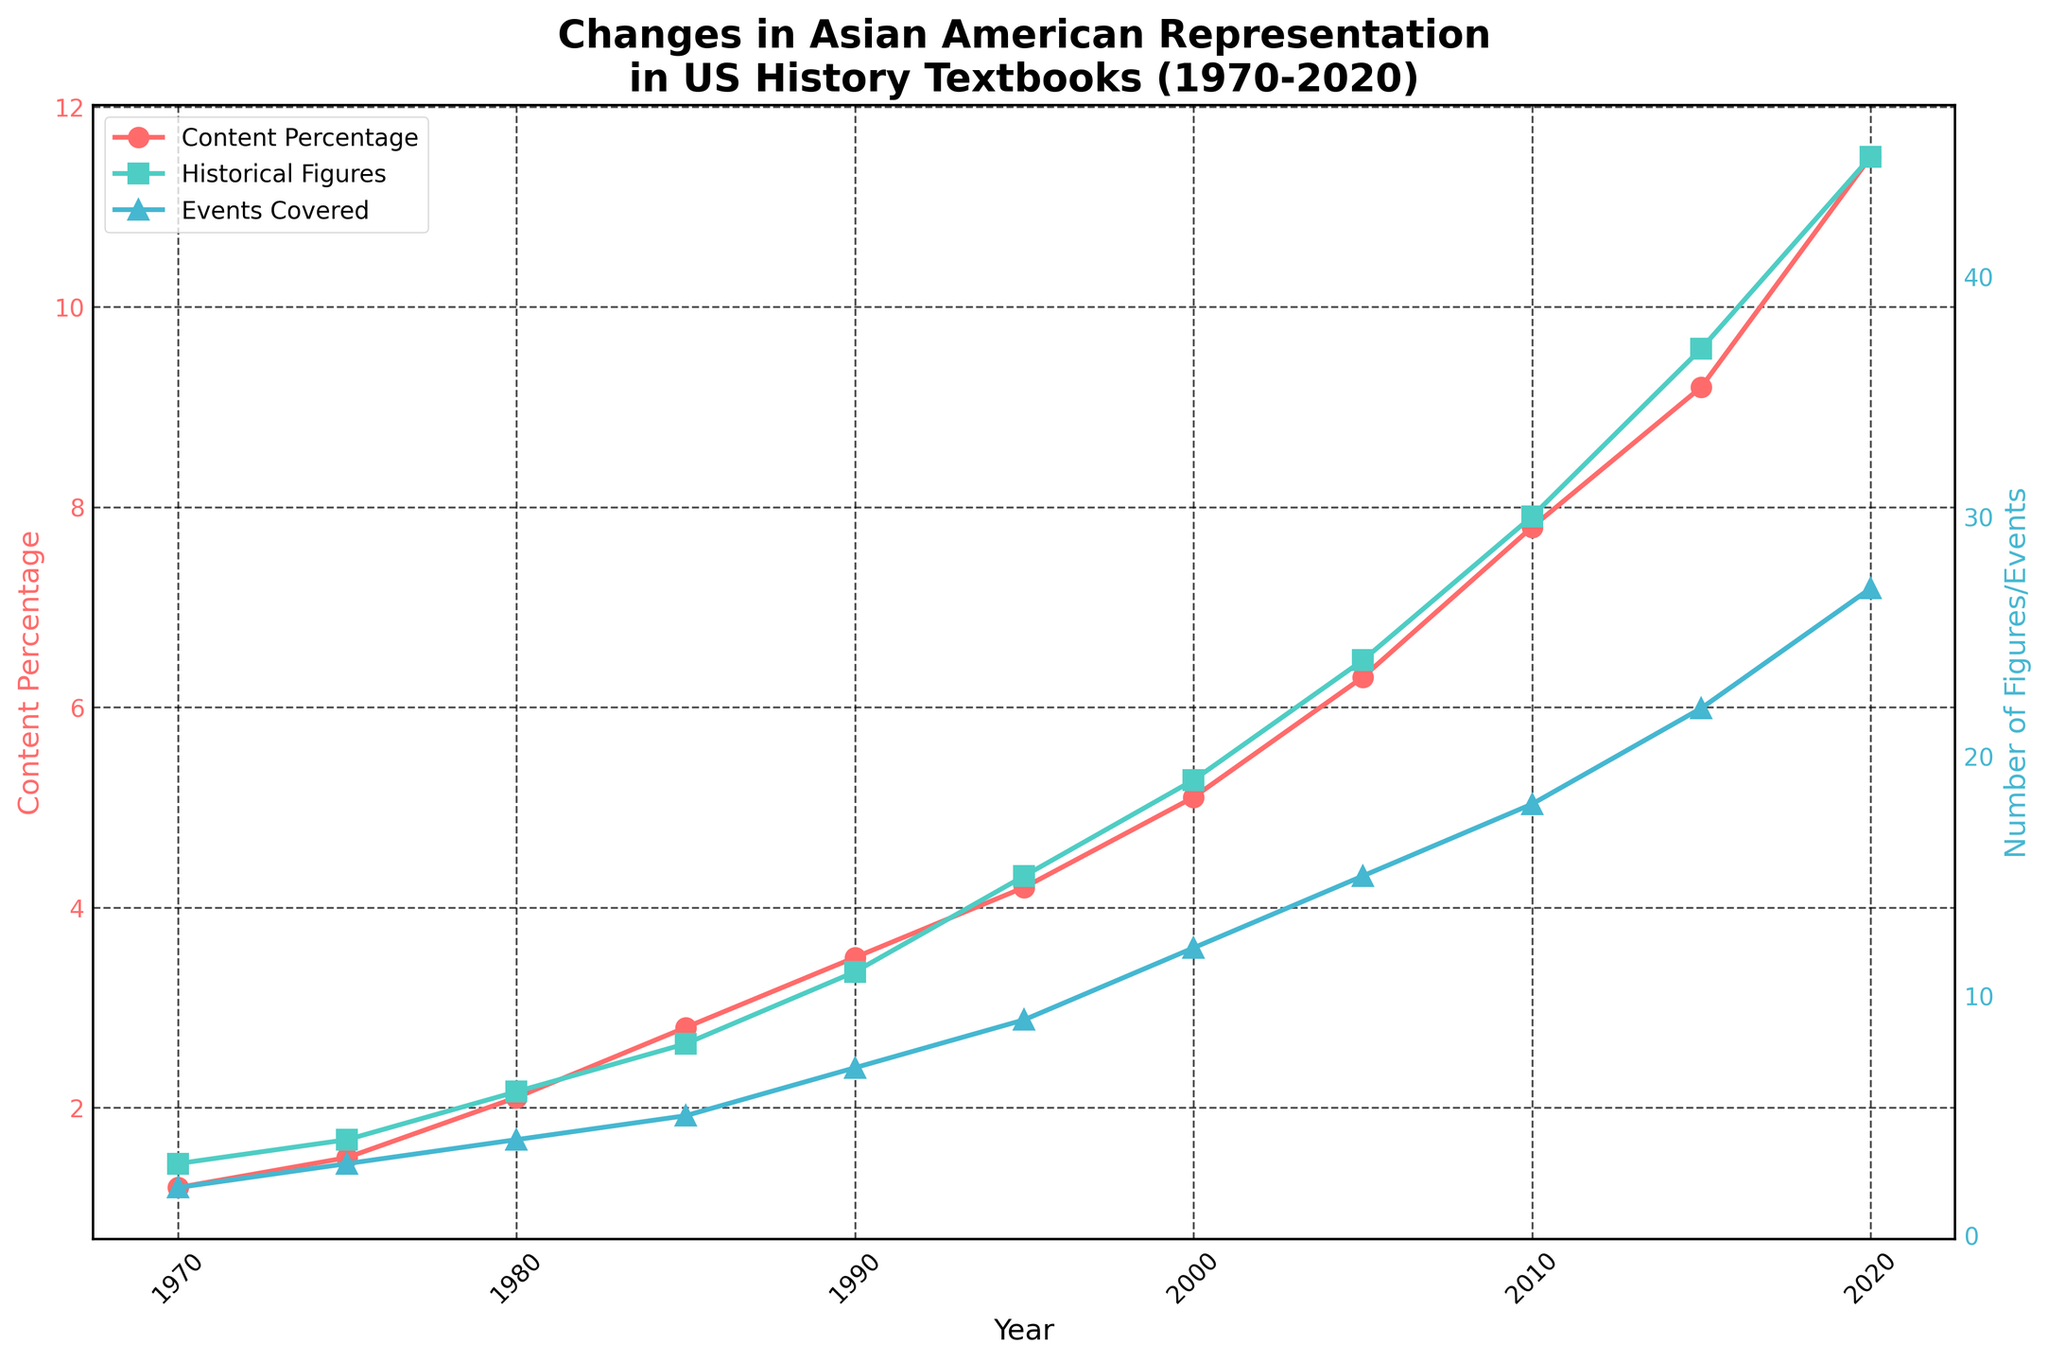What's the trend in the Content Percentage of Asian American representation from 1970 to 2020? The line representing "Content Percentage" increases steadily from 1.2% in 1970 to 11.5% in 2020, indicating a positive trend.
Answer: Positive trend How many historical figures were mentioned in 2010, and how does it compare with 1970? In 2010, the number of historical figures mentioned is 30, while in 1970, it was only 3. The number has increased significantly by 27 figures.
Answer: 30, 27 more By how much did the number of Asian American events covered increase from 2005 to 2020? In 2005, the number of events was 15, and it increased to 27 by 2020. The increase is thus 27 - 15 = 12.
Answer: 12 What year saw the highest number of historical figures mentioned? By examining the chart, the year with the highest number of historical figures mentioned is 2020 with 45 figures.
Answer: 2020 Compare the increase in Content Percentage from 1970 to 1995 and from 1995 to 2020. Which period saw a greater increase? From 1970 to 1995, the Content Percentage increased from 1.2% to 4.2%, which is an increase of 3%. From 1995 to 2020, it increased from 4.2% to 11.5%, an increase of 7.3%. The latter period saw a greater increase.
Answer: 1995 to 2020 What is the average number of historical figures mentioned every decade? To find the average per decade, sum the number of historical figures for each decade and divide by the number of decades. Summing all figures (3+4+6+8+11+15+19+24+30+37+45 = 202) and dividing by 11 decades gives approximately 18.36.
Answer: 18.36 Was there a year when the Content Percentage did not increase compared to the previous interval? By examining the line chart for "Content Percentage", there is no year where the Content Percentage did not increase compared to the previous interval. It shows a steady increase throughout the years.
Answer: No Which of the three tracked metrics (percentage, figures, or events) shows the most dramatic increase visually on the chart? Visually, the "Content Percentage" line shows the steepest increase, especially towards later years, reaching up to 11.5% by 2020.
Answer: Content Percentage 